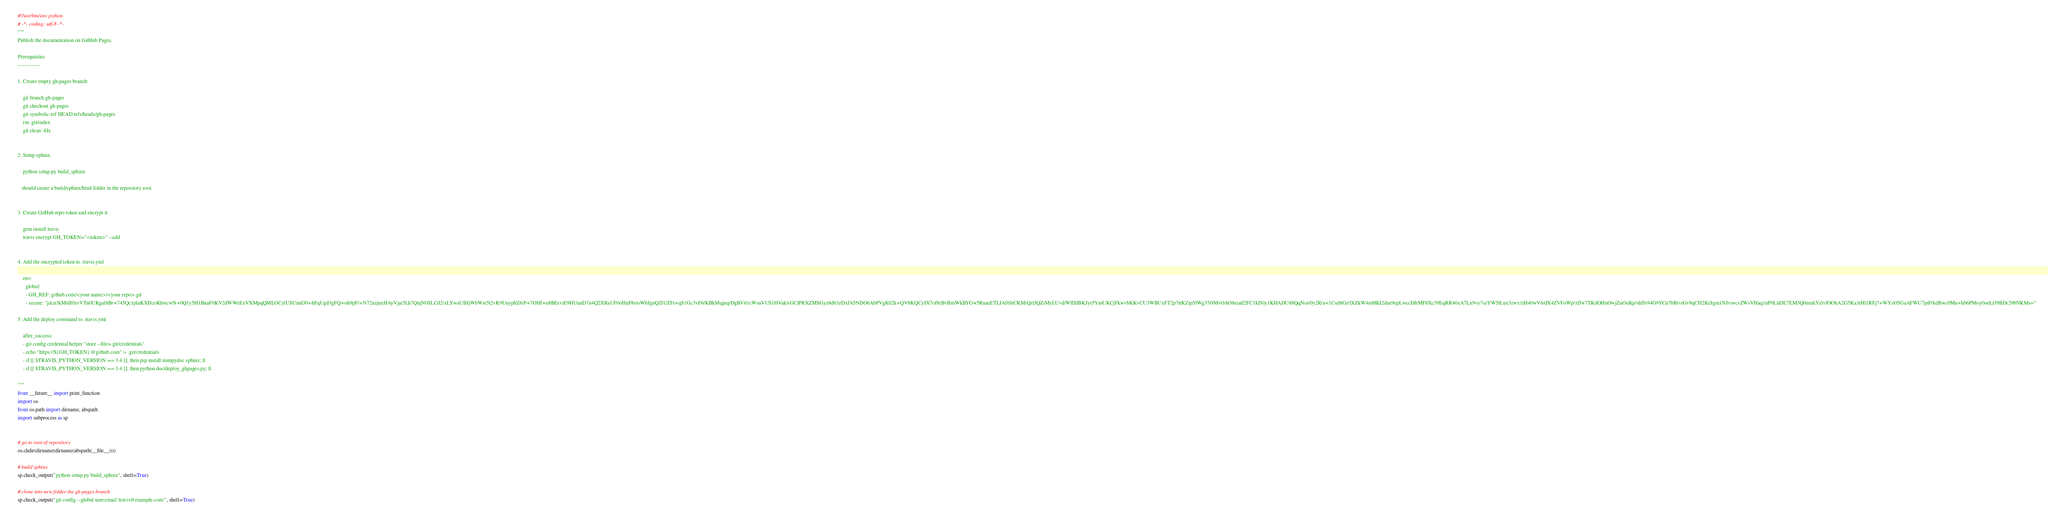Convert code to text. <code><loc_0><loc_0><loc_500><loc_500><_Python_>#!/usr/bin/env python
# -*- coding: utf-8 -*-
"""
Publish the documentation on GitHub Pages.

Prerequisites
-------------

1. Create empty gh-pages branch:

    git branch gh-pages
    git checkout gh-pages
    git symbolic-ref HEAD refs/heads/gh-pages
    rm .git/index
    git clean -fdx


2. Setup sphinx.

    python setup.py build_sphinx
   
   should create a build/sphinx/html folder in the repository root. 


3. Create GitHub repo token and encrypt it 

    gem install travis
    travis encrypt GH_TOKEN="<token>" --add
    

4. Add the encrypted token to .travis.yml

    env:
      global:
      - GH_REF: github.com/<your name>/<your repo>.git
      - secure: "jdcn3kM/dI0zvVTn0UKgal8Br+745Qc1plaKXHcoKhwcwN+0Q1y5H1BnaF0KV2dWWeExVXMpqQMLOCylUSUmd30+hFqUgd3gFQ+oh9pF/+N72uzjnxHAyVjai5Lh7QnjN0SLCd2/xLYwaUIHjWbWsr5t2vK9UuyphZ6/F+7OHf+u8BErviE9HUunD7u4Q2XRaUF0oHuF8stoWbJgnQZtUZFr+qS1Gc3vF6/KBkMqjnq/DgBV61cWsnVUS1HVak/sGClPRXZMSGyz8d63zDxfA5NDO6AbPVgK02k+QV8KQCyIX7of8rBvBmWkBYGw5RnaeETLIAf6JrCKMiQzlJQZiMyLUvd/WflSIBKJyr5YmUKCjFkwvbKKvCU3WBUxFT2p7trKZip5JWg37OMvOAO8eiatf2FC1klNly1KHADU88QqNoi/0y2R/a+1Csrl8Gr/lXZkW4mMkI2due9epLwccDJtMF8Xc39EqRR46xA7Lx9vy7szYW5lLux3zwx1tH40wV6/dX4ZVFoWp/zfJw7TKdOHuOwjZuOuKp/shfJs94G9YCu7bBtvrGv9qCH2KiSgm1NJviwcsZWsVHaq1nP0LliDE7EM3Q0mnkYzlvfOOhA2G5Ka3rHl1RFj7+WYzO5GaAFWU7piP/kdBwc0Mu+hb6PMoy0oeLt39BDr29bNKMs="

5. Add the deploy command to .travis.yml

    after_success:
    - git config credential.helper "store --file=.git/credentials"
    - echo "https://${GH_TOKEN}:@github.com" > .git/credentials
    - if [[ $TRAVIS_PYTHON_VERSION == 3.4 ]]; then pip install numpydoc sphinx; fi
    - if [[ $TRAVIS_PYTHON_VERSION == 3.4 ]]; then python doc/deploy_ghpages.py; fi

"""
from __future__ import print_function
import os
from os.path import dirname, abspath
import subprocess as sp


# go to root of repository
os.chdir(dirname(dirname(abspath(__file__))))

# build sphinx
sp.check_output("python setup.py build_sphinx", shell=True)

# clone into new folder the gh-pages branch
sp.check_output("git config --global user.email 'travis@example.com'", shell=True)</code> 